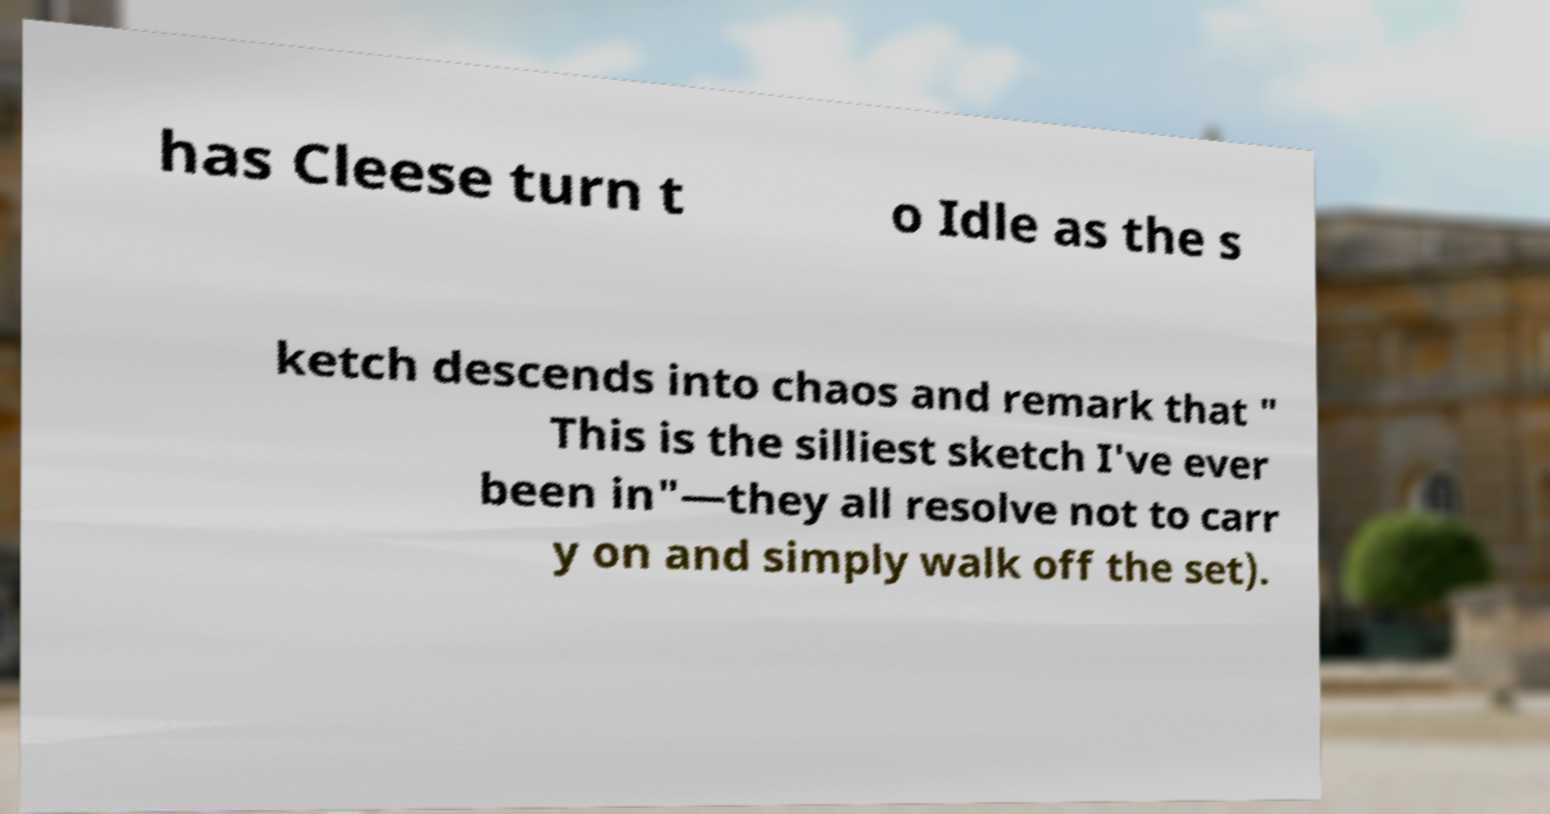What messages or text are displayed in this image? I need them in a readable, typed format. has Cleese turn t o Idle as the s ketch descends into chaos and remark that " This is the silliest sketch I've ever been in"—they all resolve not to carr y on and simply walk off the set). 